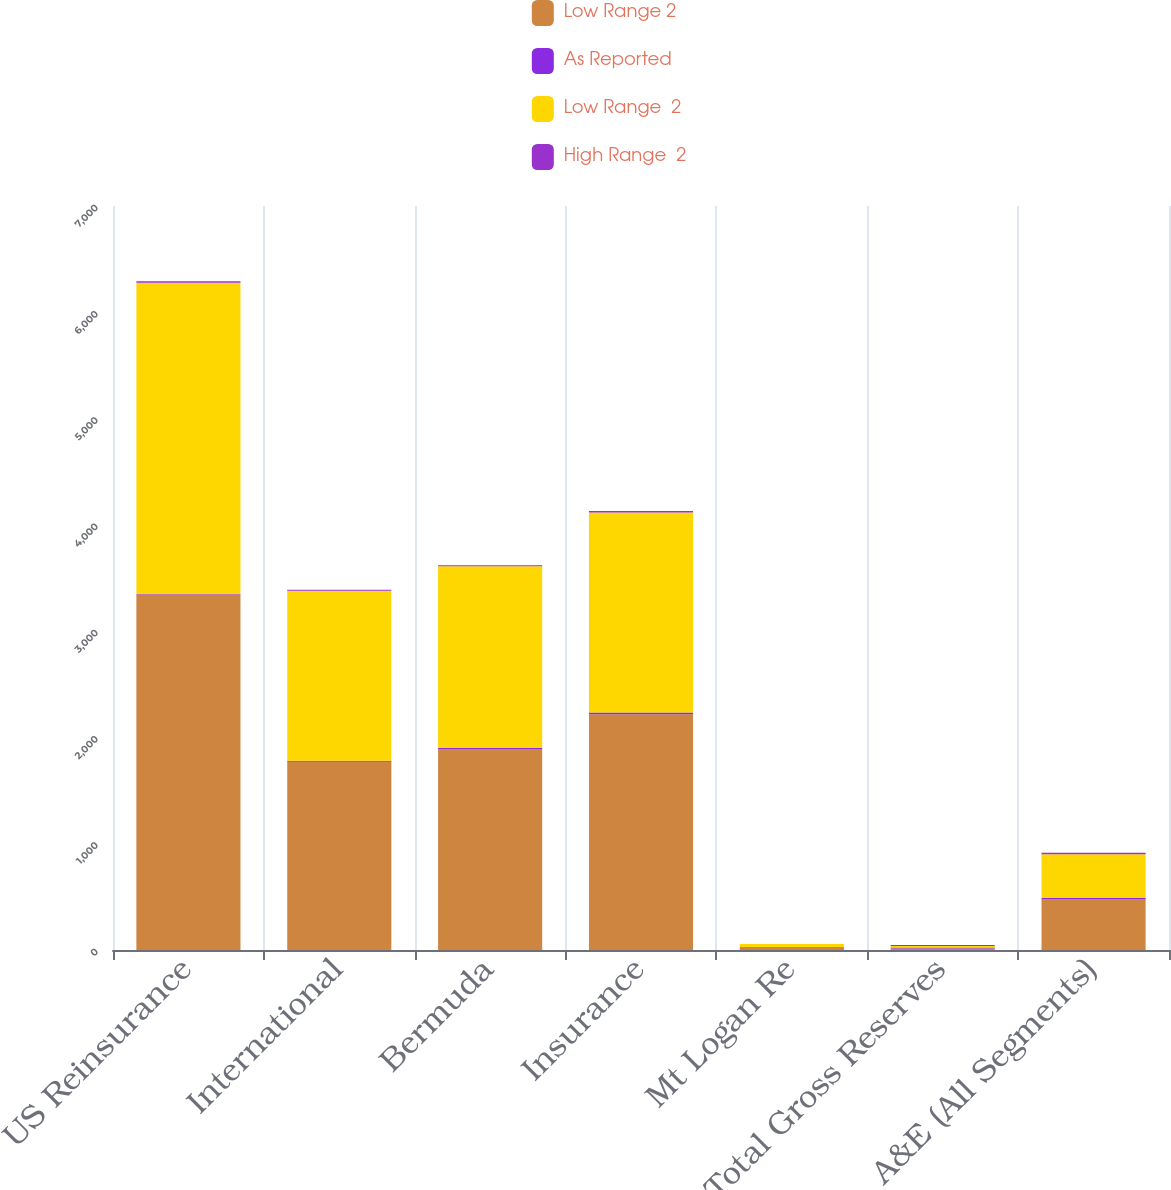Convert chart. <chart><loc_0><loc_0><loc_500><loc_500><stacked_bar_chart><ecel><fcel>US Reinsurance<fcel>International<fcel>Bermuda<fcel>Insurance<fcel>Mt Logan Re<fcel>Total Gross Reserves<fcel>A&E (All Segments)<nl><fcel>Low Range 2<fcel>3334.9<fcel>1771<fcel>1892<fcel>2218.6<fcel>28<fcel>14.45<fcel>476.2<nl><fcel>As Reported<fcel>12.1<fcel>9.7<fcel>9.7<fcel>15.2<fcel>0<fcel>8.8<fcel>13.7<nl><fcel>Low Range  2<fcel>2932<fcel>1599.5<fcel>1708.4<fcel>1881.7<fcel>28<fcel>14.45<fcel>411<nl><fcel>High Range  2<fcel>12.1<fcel>9.7<fcel>9.7<fcel>15.2<fcel>0<fcel>8.8<fcel>13.7<nl></chart> 